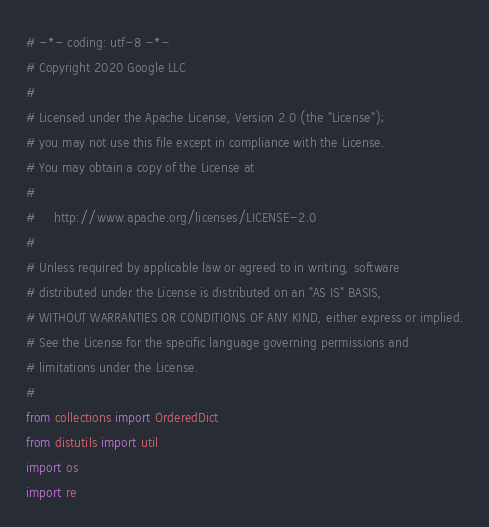Convert code to text. <code><loc_0><loc_0><loc_500><loc_500><_Python_># -*- coding: utf-8 -*-
# Copyright 2020 Google LLC
#
# Licensed under the Apache License, Version 2.0 (the "License");
# you may not use this file except in compliance with the License.
# You may obtain a copy of the License at
#
#     http://www.apache.org/licenses/LICENSE-2.0
#
# Unless required by applicable law or agreed to in writing, software
# distributed under the License is distributed on an "AS IS" BASIS,
# WITHOUT WARRANTIES OR CONDITIONS OF ANY KIND, either express or implied.
# See the License for the specific language governing permissions and
# limitations under the License.
#
from collections import OrderedDict
from distutils import util
import os
import re</code> 